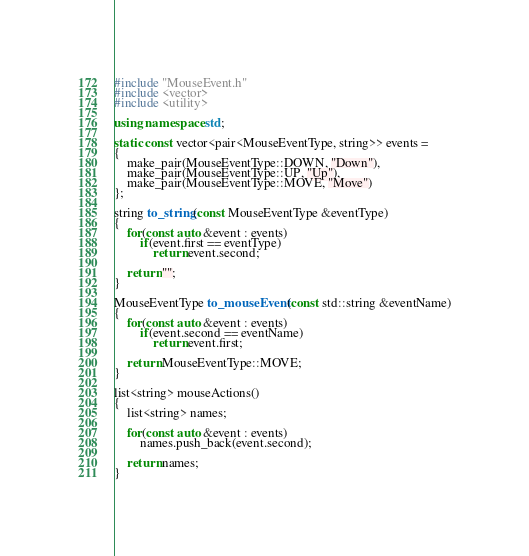Convert code to text. <code><loc_0><loc_0><loc_500><loc_500><_C++_>#include "MouseEvent.h"
#include <vector>
#include <utility>

using namespace std;

static const vector<pair<MouseEventType, string>> events =
{
    make_pair(MouseEventType::DOWN, "Down"),
    make_pair(MouseEventType::UP, "Up"),
    make_pair(MouseEventType::MOVE, "Move")
};

string to_string(const MouseEventType &eventType)
{
    for(const auto &event : events)
        if(event.first == eventType)
            return event.second;

    return "";
}

MouseEventType to_mouseEvent(const std::string &eventName)
{
    for(const auto &event : events)
        if(event.second == eventName)
            return event.first;

    return MouseEventType::MOVE;
}

list<string> mouseActions()
{
    list<string> names;

    for(const auto &event : events)
        names.push_back(event.second);

    return names;
}
</code> 